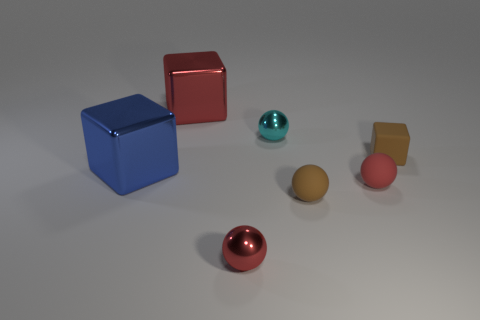Subtract all cyan balls. How many balls are left? 3 Subtract all purple cubes. How many red spheres are left? 2 Add 3 brown objects. How many objects exist? 10 Subtract 3 balls. How many balls are left? 1 Subtract all brown blocks. How many blocks are left? 2 Add 5 tiny cyan balls. How many tiny cyan balls are left? 6 Add 3 spheres. How many spheres exist? 7 Subtract 1 blue blocks. How many objects are left? 6 Subtract all balls. How many objects are left? 3 Subtract all red balls. Subtract all yellow cylinders. How many balls are left? 2 